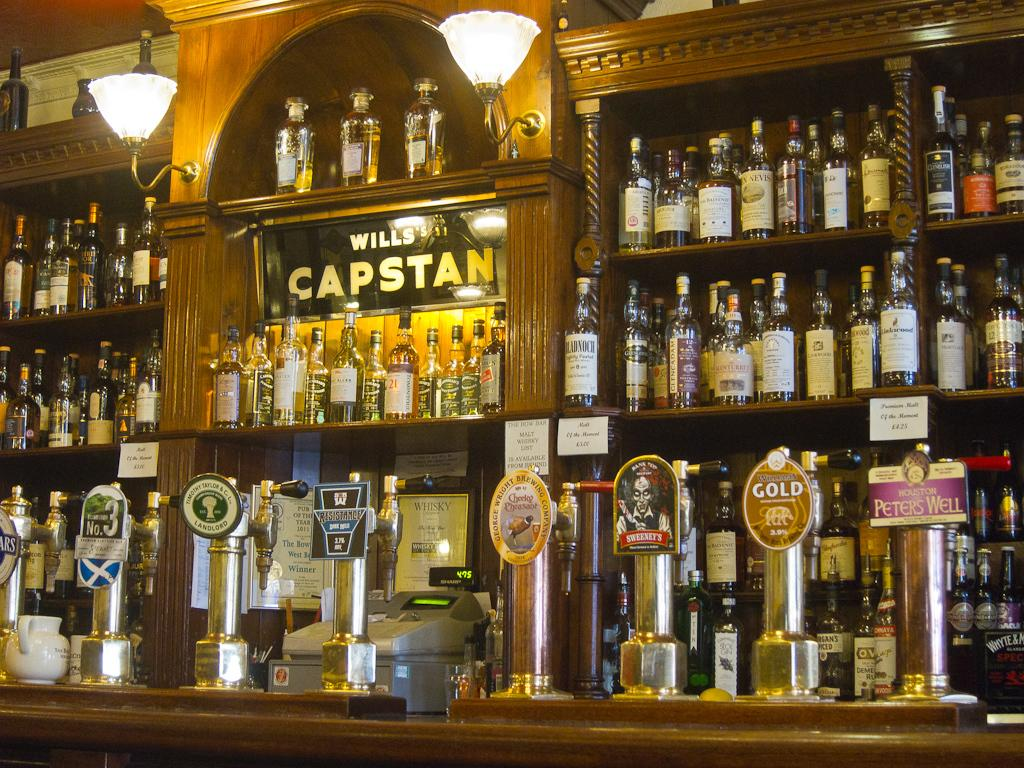What is the main subject of the image? The main subject of the image is many bottles. Where are the bottles located in the image? The bottles are placed on a shelf. What other objects can be seen in the image? There is a light attached to a cupboard and a machine on a table in the image. What type of slope can be seen in the image? There is no slope present in the image. Is there a band playing music in the image? There is no band present in the image. 